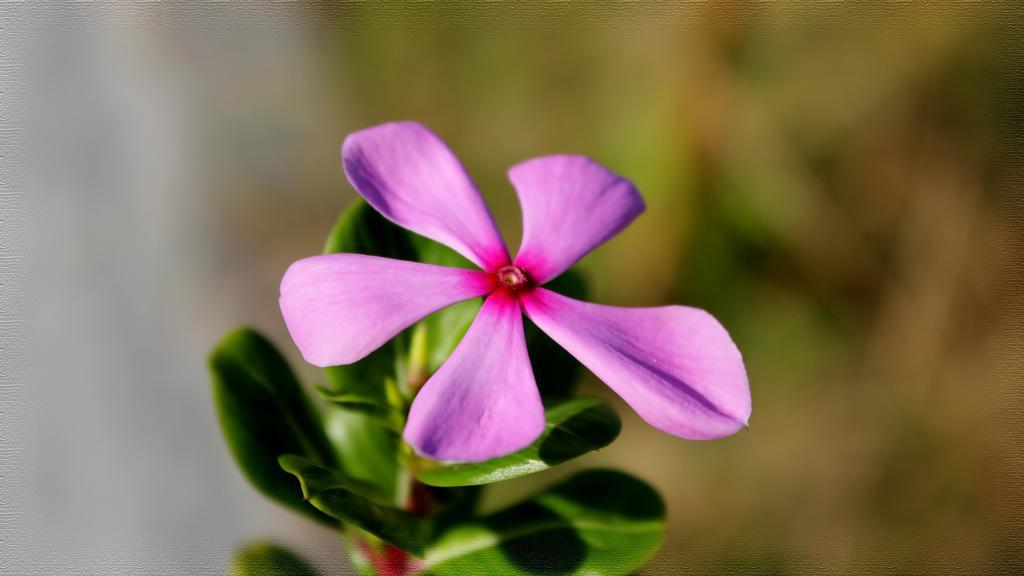Please provide a concise description of this image. In this image we can see a purple color flower to the plant and the background is blurred. 